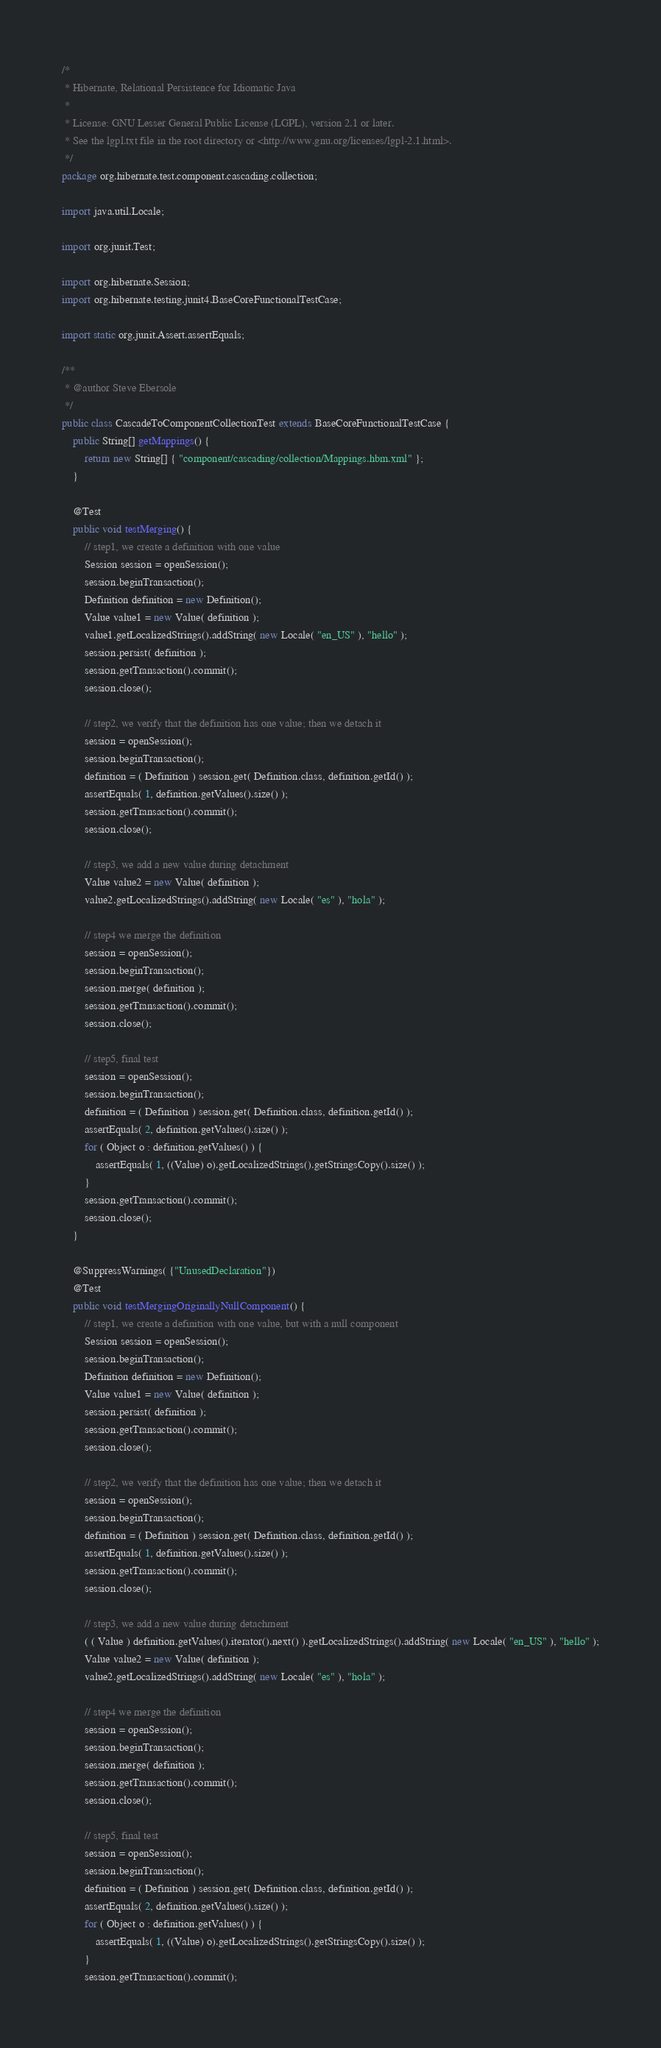Convert code to text. <code><loc_0><loc_0><loc_500><loc_500><_Java_>/*
 * Hibernate, Relational Persistence for Idiomatic Java
 *
 * License: GNU Lesser General Public License (LGPL), version 2.1 or later.
 * See the lgpl.txt file in the root directory or <http://www.gnu.org/licenses/lgpl-2.1.html>.
 */
package org.hibernate.test.component.cascading.collection;

import java.util.Locale;

import org.junit.Test;

import org.hibernate.Session;
import org.hibernate.testing.junit4.BaseCoreFunctionalTestCase;

import static org.junit.Assert.assertEquals;

/**
 * @author Steve Ebersole
 */
public class CascadeToComponentCollectionTest extends BaseCoreFunctionalTestCase {
	public String[] getMappings() {
		return new String[] { "component/cascading/collection/Mappings.hbm.xml" };
	}

	@Test
	public void testMerging() {
		// step1, we create a definition with one value
		Session session = openSession();
		session.beginTransaction();
		Definition definition = new Definition();
		Value value1 = new Value( definition );
		value1.getLocalizedStrings().addString( new Locale( "en_US" ), "hello" );
		session.persist( definition );
		session.getTransaction().commit();
		session.close();

		// step2, we verify that the definition has one value; then we detach it
		session = openSession();
		session.beginTransaction();
		definition = ( Definition ) session.get( Definition.class, definition.getId() );
		assertEquals( 1, definition.getValues().size() );
		session.getTransaction().commit();
		session.close();

		// step3, we add a new value during detachment
		Value value2 = new Value( definition );
		value2.getLocalizedStrings().addString( new Locale( "es" ), "hola" );

		// step4 we merge the definition
		session = openSession();
		session.beginTransaction();
		session.merge( definition );
		session.getTransaction().commit();
		session.close();

		// step5, final test
		session = openSession();
		session.beginTransaction();
		definition = ( Definition ) session.get( Definition.class, definition.getId() );
		assertEquals( 2, definition.getValues().size() );
		for ( Object o : definition.getValues() ) {
			assertEquals( 1, ((Value) o).getLocalizedStrings().getStringsCopy().size() );
		}
		session.getTransaction().commit();
		session.close();
	}

	@SuppressWarnings( {"UnusedDeclaration"})
	@Test
	public void testMergingOriginallyNullComponent() {
		// step1, we create a definition with one value, but with a null component
		Session session = openSession();
		session.beginTransaction();
		Definition definition = new Definition();
		Value value1 = new Value( definition );
		session.persist( definition );
		session.getTransaction().commit();
		session.close();

		// step2, we verify that the definition has one value; then we detach it
		session = openSession();
		session.beginTransaction();
		definition = ( Definition ) session.get( Definition.class, definition.getId() );
		assertEquals( 1, definition.getValues().size() );
		session.getTransaction().commit();
		session.close();

		// step3, we add a new value during detachment
		( ( Value ) definition.getValues().iterator().next() ).getLocalizedStrings().addString( new Locale( "en_US" ), "hello" );
		Value value2 = new Value( definition );
		value2.getLocalizedStrings().addString( new Locale( "es" ), "hola" );

		// step4 we merge the definition
		session = openSession();
		session.beginTransaction();
		session.merge( definition );
		session.getTransaction().commit();
		session.close();

		// step5, final test
		session = openSession();
		session.beginTransaction();
		definition = ( Definition ) session.get( Definition.class, definition.getId() );
		assertEquals( 2, definition.getValues().size() );
		for ( Object o : definition.getValues() ) {
			assertEquals( 1, ((Value) o).getLocalizedStrings().getStringsCopy().size() );
		}
		session.getTransaction().commit();</code> 